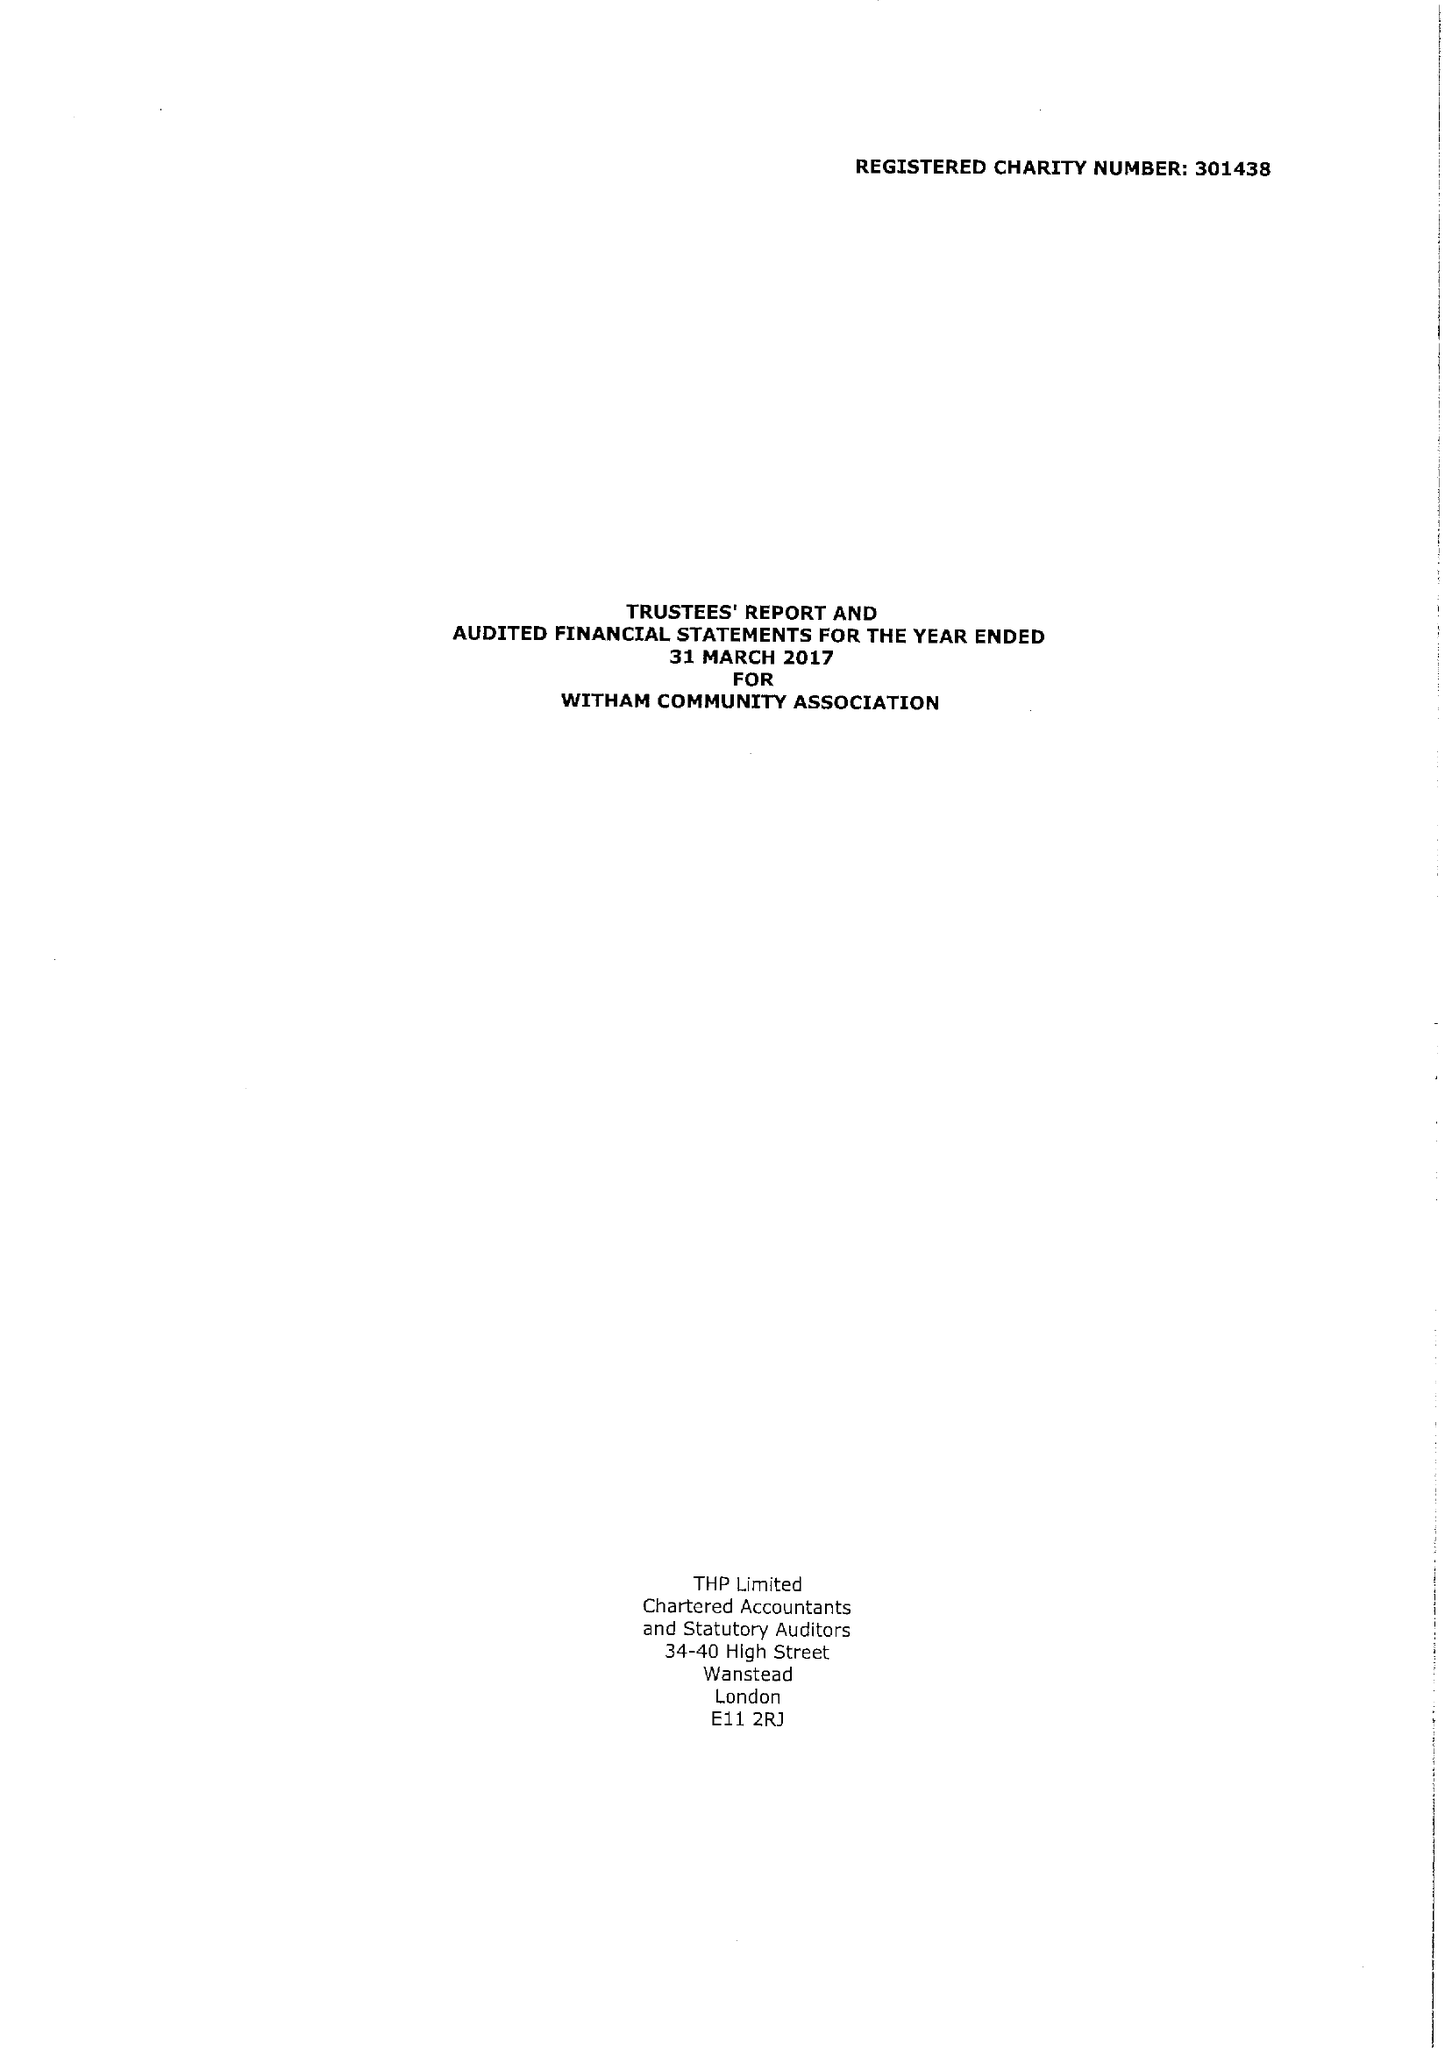What is the value for the charity_name?
Answer the question using a single word or phrase. Witham Community Association 